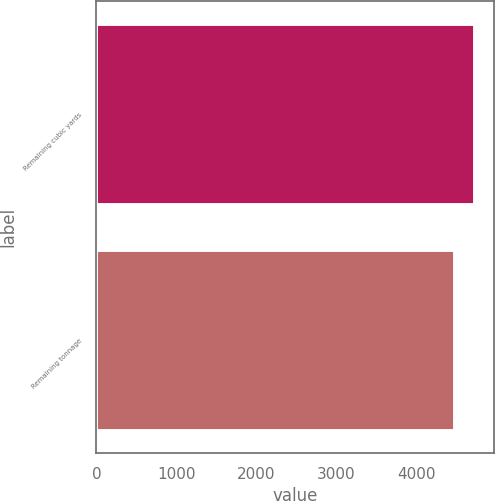<chart> <loc_0><loc_0><loc_500><loc_500><bar_chart><fcel>Remaining cubic yards<fcel>Remaining tonnage<nl><fcel>4730<fcel>4485<nl></chart> 